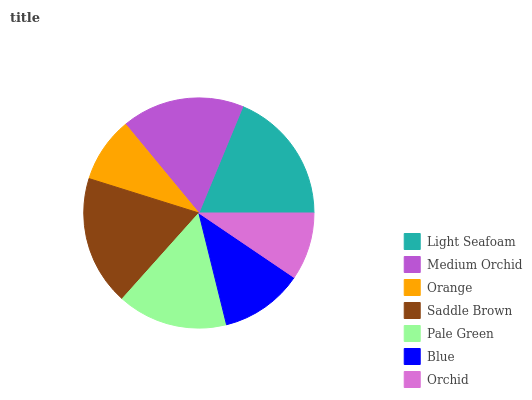Is Orange the minimum?
Answer yes or no. Yes. Is Light Seafoam the maximum?
Answer yes or no. Yes. Is Medium Orchid the minimum?
Answer yes or no. No. Is Medium Orchid the maximum?
Answer yes or no. No. Is Light Seafoam greater than Medium Orchid?
Answer yes or no. Yes. Is Medium Orchid less than Light Seafoam?
Answer yes or no. Yes. Is Medium Orchid greater than Light Seafoam?
Answer yes or no. No. Is Light Seafoam less than Medium Orchid?
Answer yes or no. No. Is Pale Green the high median?
Answer yes or no. Yes. Is Pale Green the low median?
Answer yes or no. Yes. Is Light Seafoam the high median?
Answer yes or no. No. Is Blue the low median?
Answer yes or no. No. 